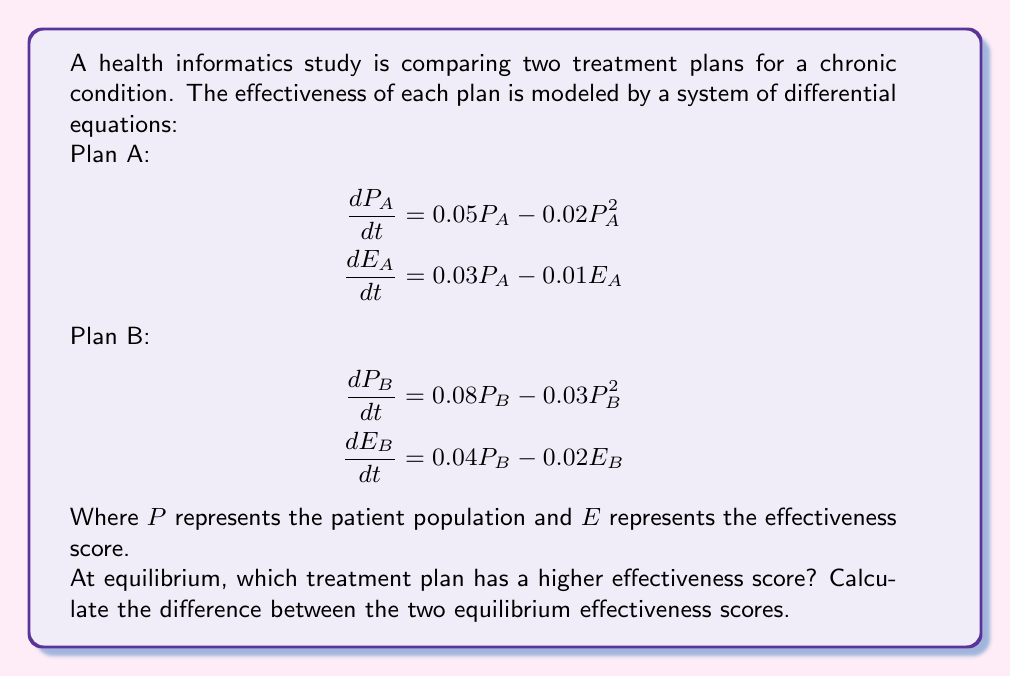Solve this math problem. To solve this problem, we need to follow these steps:

1) Find the equilibrium points for both plans by setting the derivatives to zero.

2) Solve for $P$ and $E$ at equilibrium for each plan.

3) Compare the equilibrium effectiveness scores.

For Plan A:

1) Set derivatives to zero:
   $$0 = 0.05P_A - 0.02P_A^2$$
   $$0 = 0.03P_A - 0.01E_A$$

2) Solve for $P_A$:
   $$0.05P_A - 0.02P_A^2 = 0$$
   $$P_A(0.05 - 0.02P_A) = 0$$
   $$P_A = 0 \text{ or } P_A = 2.5$$

   The non-zero equilibrium is $P_A = 2.5$

3) Solve for $E_A$:
   $$0 = 0.03P_A - 0.01E_A$$
   $$E_A = 3P_A = 3(2.5) = 7.5$$

For Plan B:

1) Set derivatives to zero:
   $$0 = 0.08P_B - 0.03P_B^2$$
   $$0 = 0.04P_B - 0.02E_B$$

2) Solve for $P_B$:
   $$0.08P_B - 0.03P_B^2 = 0$$
   $$P_B(0.08 - 0.03P_B) = 0$$
   $$P_B = 0 \text{ or } P_B = \frac{8}{3} \approx 2.67$$

   The non-zero equilibrium is $P_B = \frac{8}{3}$

3) Solve for $E_B$:
   $$0 = 0.04P_B - 0.02E_B$$
   $$E_B = 2P_B = 2(\frac{8}{3}) = \frac{16}{3} \approx 5.33$$

Comparing the equilibrium effectiveness scores:
Plan A: $E_A = 7.5$
Plan B: $E_B = \frac{16}{3} \approx 5.33$

Plan A has a higher effectiveness score at equilibrium.

The difference between the two equilibrium effectiveness scores is:
$$7.5 - \frac{16}{3} = \frac{22.5 - 16}{3} = \frac{6.5}{3} \approx 2.17$$
Answer: Plan A; $\frac{6.5}{3}$ 